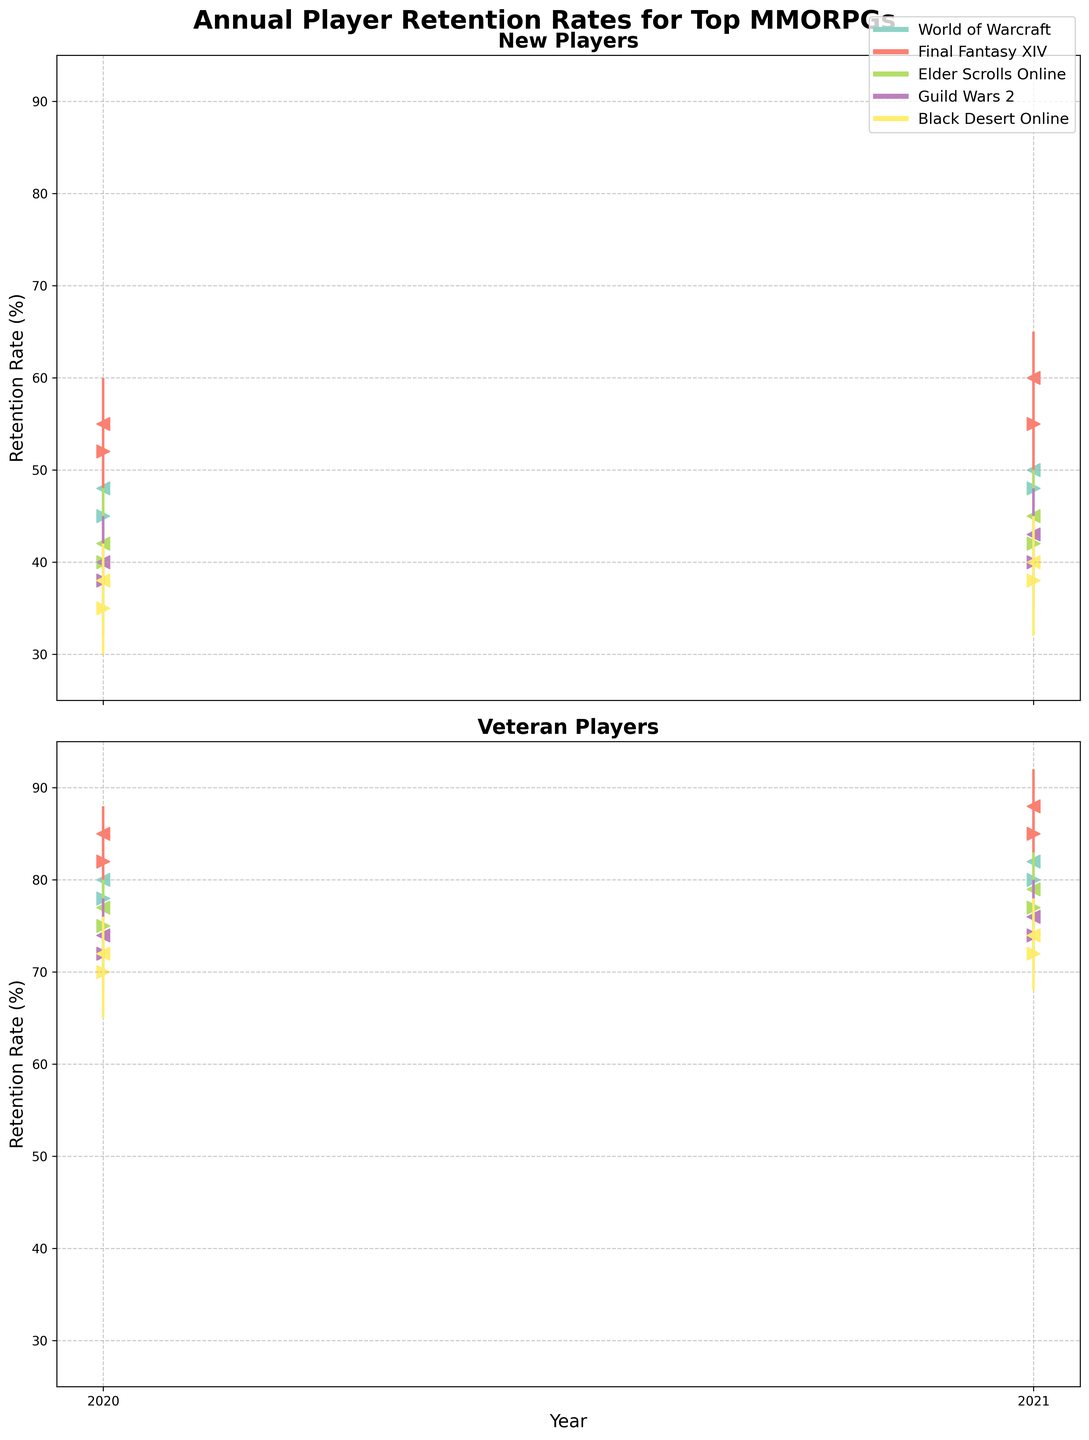What is the highest retention rate for new players of Final Fantasy XIV in 2021? Check the topmost point in the New Players section for Final Fantasy XIV in 2021, which is marked by a vertical line denoting the high value. The highest retention rate is 65%.
Answer: 65% What is the difference in the 2021 close rates for new and veteran players in Elder Scrolls Online? Look at the closing markers (<) for Elder Scrolls Online in 2021 for both new and veteran players. Subtract the new players' close rate (45%) from the veteran players' close rate (79%). The difference is 79% - 45% = 34%.
Answer: 34% Which game had the lowest retention rate for new players in 2020, and what was the rate? Look at all the lowest points in the New Players section for 2020. The lowest point is Black Desert Online with a retention rate of 30%.
Answer: Black Desert Online, 30% Which game's veteran players had the highest retention rate in 2020, and what was it? Check the highest points in the Veteran Players section for 2020. Final Fantasy XIV has the highest retention rate at 88%.
Answer: Final Fantasy XIV, 88% Which game showed the most significant increase in the close rate for new players from 2020 to 2021? Calculate the difference in the New Players' close rate from 2020 to 2021 for all games: 
1) World of Warcraft: 50 - 48 = 2 
2) Final Fantasy XIV: 60 - 55 = 5 
3) Elder Scrolls Online: 45 - 42 = 3 
4) Guild Wars 2: 43 - 40 = 3 
5) Black Desert Online: 40 - 38 = 2 
Final Fantasy XIV showed the most significant increase, with a difference of 5%.
Answer: Final Fantasy XIV with 5% How did the open and close rates for veteran players of Guild Wars 2 change between 2020 and 2021? For Guild Wars 2: 
1) Open Rate 2020 vs 2021: 72% to 74% (an increase of 2%) 
2) Close Rate 2020 vs 2021: 74% to 76% (an increase of 2%) 
Both the open and close rates increased by 2%.
Answer: Both increased by 2% Which game had the smallest spread (High - Low) for new players in 2021, and what was the spread? Calculate spreads for new players in 2021: 
1) World of Warcraft: 55 - 40 = 15 
2) Final Fantasy XIV: 65 - 50 = 15 
3) Elder Scrolls Online: 50 - 37 = 13 
4) Guild Wars 2: 48 - 35 = 13 
5) Black Desert Online: 45 - 32 = 13 
The smallest spread is 13%, shared by Elder Scrolls Online, Guild Wars 2, and Black Desert Online.
Answer: Elder Scrolls Online, Guild Wars 2, Black Desert Online, 13% What was the closing retention rate for new players for World of Warcraft in both years? Look at the closing markers (<) in the New Players section for World of Warcraft in the years 2020 and 2021. The closing rates are 48% and 50%, respectively.
Answer: 48% and 50% 